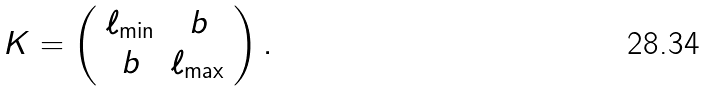<formula> <loc_0><loc_0><loc_500><loc_500>K = \left ( \begin{array} { c c } \ell _ { \min } & b \\ b & \ell _ { \max } \\ \end{array} \right ) .</formula> 